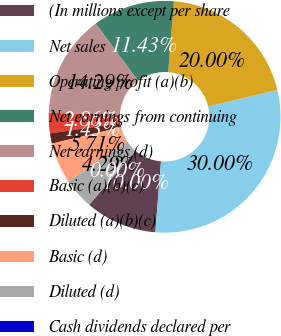Convert chart to OTSL. <chart><loc_0><loc_0><loc_500><loc_500><pie_chart><fcel>(In millions except per share<fcel>Net sales<fcel>Operating profit (a)(b)<fcel>Net earnings from continuing<fcel>Net earnings (d)<fcel>Basic (a)(b)(c)<fcel>Diluted (a)(b)(c)<fcel>Basic (d)<fcel>Diluted (d)<fcel>Cash dividends declared per<nl><fcel>10.0%<fcel>30.0%<fcel>20.0%<fcel>11.43%<fcel>14.29%<fcel>2.86%<fcel>1.43%<fcel>5.71%<fcel>4.29%<fcel>0.0%<nl></chart> 